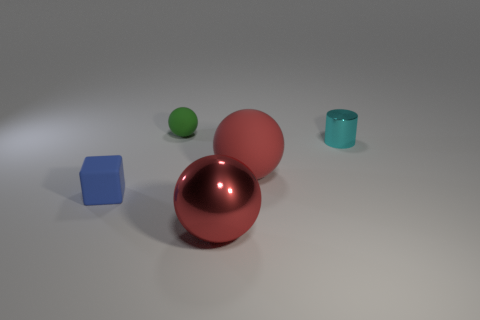What colors are the objects in the picture? The objects in the image feature a range of colors: one is blue, the smaller sphere is green, the cylinder or cup is teal, and the two larger spheres are a glossy red or maroon. 